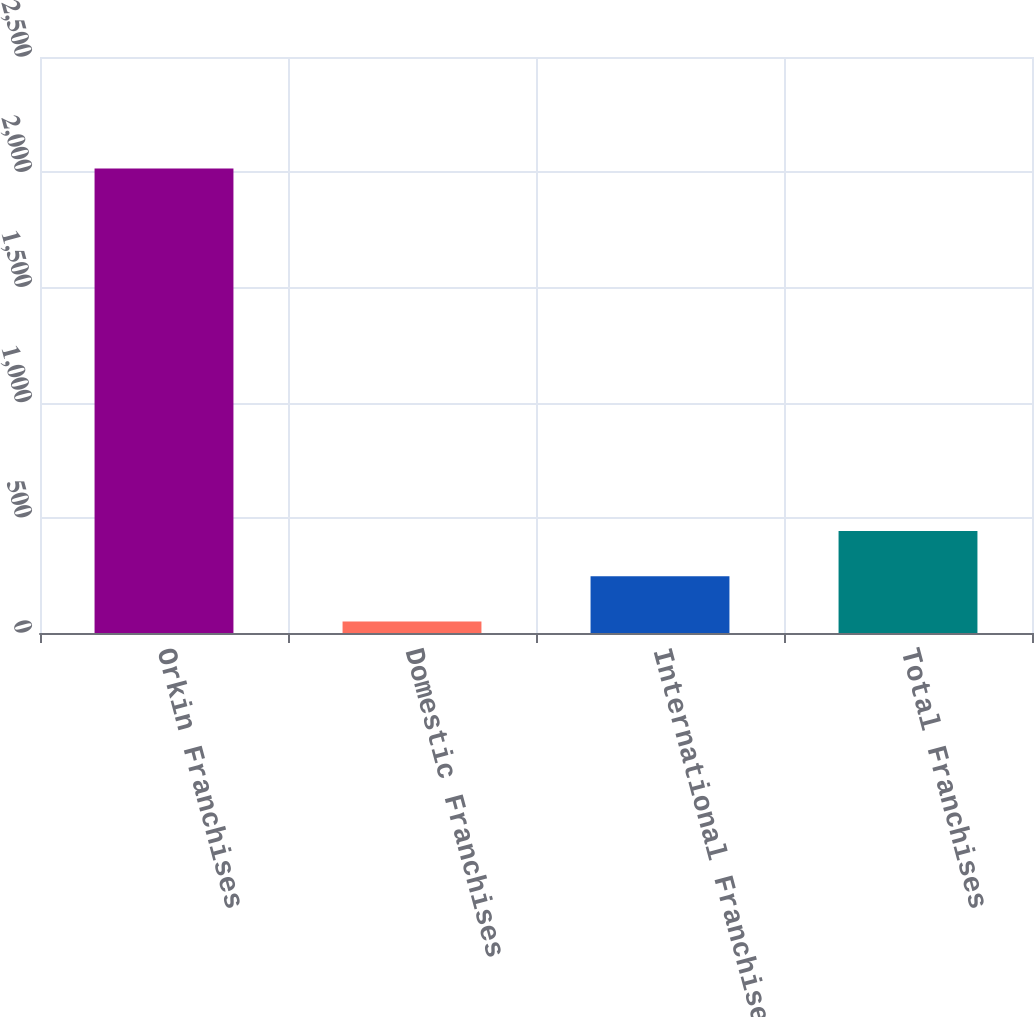Convert chart to OTSL. <chart><loc_0><loc_0><loc_500><loc_500><bar_chart><fcel>Orkin Franchises<fcel>Domestic Franchises<fcel>International Franchises<fcel>Total Franchises<nl><fcel>2016<fcel>50<fcel>246.6<fcel>443.2<nl></chart> 